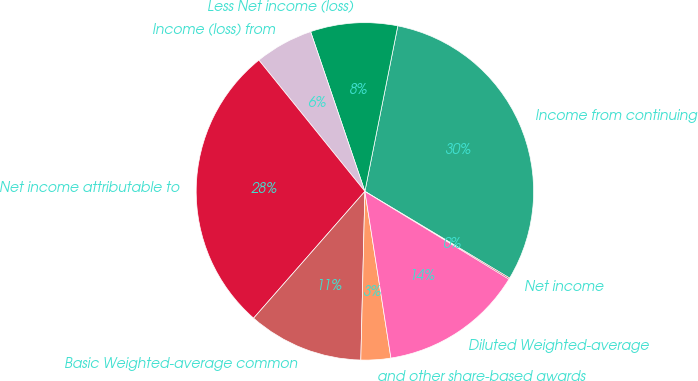<chart> <loc_0><loc_0><loc_500><loc_500><pie_chart><fcel>Income from continuing<fcel>Less Net income (loss)<fcel>Income (loss) from<fcel>Net income attributable to<fcel>Basic Weighted-average common<fcel>and other share-based awards<fcel>Diluted Weighted-average<fcel>Net income<nl><fcel>30.47%<fcel>8.34%<fcel>5.6%<fcel>27.72%<fcel>11.08%<fcel>2.85%<fcel>13.83%<fcel>0.11%<nl></chart> 